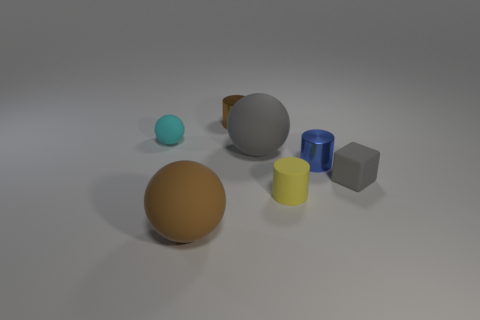Subtract all large spheres. How many spheres are left? 1 Add 1 brown shiny objects. How many objects exist? 8 Subtract all green spheres. Subtract all brown cylinders. How many spheres are left? 3 Add 6 large gray blocks. How many large gray blocks exist? 6 Subtract 1 brown cylinders. How many objects are left? 6 Subtract all blocks. How many objects are left? 6 Subtract all tiny brown objects. Subtract all small gray matte cubes. How many objects are left? 5 Add 1 small gray objects. How many small gray objects are left? 2 